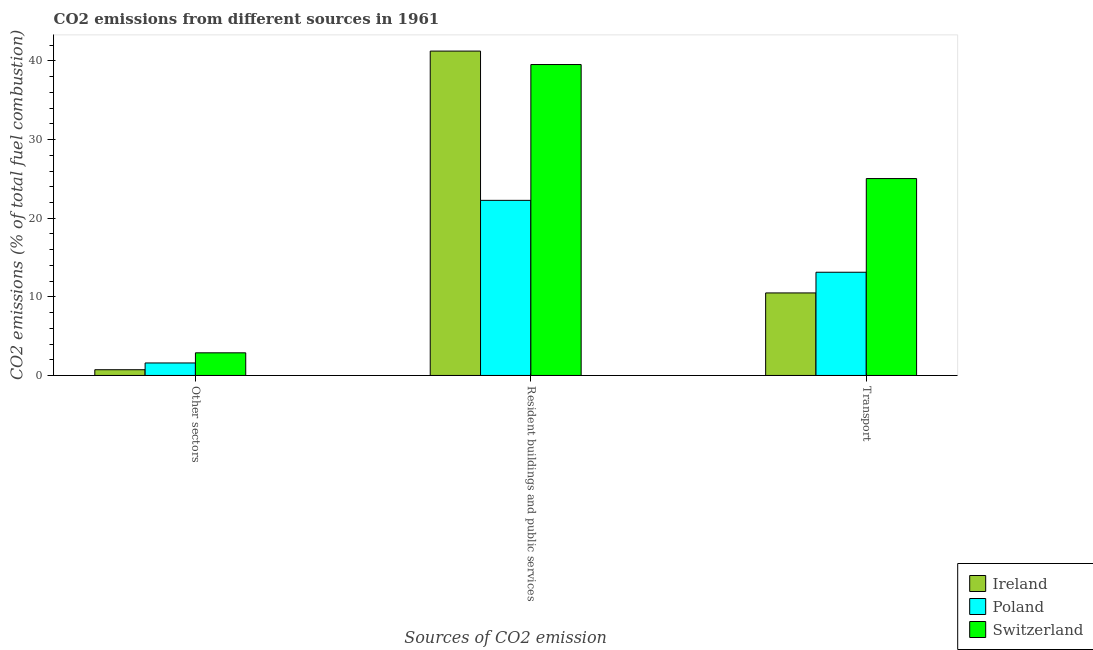How many different coloured bars are there?
Provide a succinct answer. 3. Are the number of bars on each tick of the X-axis equal?
Provide a short and direct response. Yes. How many bars are there on the 2nd tick from the right?
Offer a terse response. 3. What is the label of the 1st group of bars from the left?
Provide a short and direct response. Other sectors. What is the percentage of co2 emissions from transport in Ireland?
Make the answer very short. 10.5. Across all countries, what is the maximum percentage of co2 emissions from resident buildings and public services?
Provide a short and direct response. 41.25. Across all countries, what is the minimum percentage of co2 emissions from other sectors?
Your response must be concise. 0.73. In which country was the percentage of co2 emissions from other sectors maximum?
Keep it short and to the point. Switzerland. In which country was the percentage of co2 emissions from other sectors minimum?
Provide a short and direct response. Ireland. What is the total percentage of co2 emissions from other sectors in the graph?
Provide a succinct answer. 5.2. What is the difference between the percentage of co2 emissions from transport in Switzerland and that in Ireland?
Your answer should be very brief. 14.55. What is the difference between the percentage of co2 emissions from transport in Poland and the percentage of co2 emissions from other sectors in Ireland?
Give a very brief answer. 12.4. What is the average percentage of co2 emissions from transport per country?
Your answer should be very brief. 16.22. What is the difference between the percentage of co2 emissions from resident buildings and public services and percentage of co2 emissions from transport in Ireland?
Keep it short and to the point. 30.76. What is the ratio of the percentage of co2 emissions from transport in Switzerland to that in Ireland?
Your response must be concise. 2.39. Is the percentage of co2 emissions from transport in Ireland less than that in Poland?
Your answer should be compact. Yes. Is the difference between the percentage of co2 emissions from resident buildings and public services in Poland and Ireland greater than the difference between the percentage of co2 emissions from other sectors in Poland and Ireland?
Offer a terse response. No. What is the difference between the highest and the second highest percentage of co2 emissions from resident buildings and public services?
Keep it short and to the point. 1.71. What is the difference between the highest and the lowest percentage of co2 emissions from resident buildings and public services?
Your answer should be very brief. 18.98. In how many countries, is the percentage of co2 emissions from resident buildings and public services greater than the average percentage of co2 emissions from resident buildings and public services taken over all countries?
Provide a succinct answer. 2. Is the sum of the percentage of co2 emissions from other sectors in Ireland and Poland greater than the maximum percentage of co2 emissions from resident buildings and public services across all countries?
Keep it short and to the point. No. What does the 1st bar from the right in Transport represents?
Keep it short and to the point. Switzerland. What is the difference between two consecutive major ticks on the Y-axis?
Your response must be concise. 10. Are the values on the major ticks of Y-axis written in scientific E-notation?
Your answer should be compact. No. Does the graph contain grids?
Keep it short and to the point. No. How many legend labels are there?
Give a very brief answer. 3. What is the title of the graph?
Provide a short and direct response. CO2 emissions from different sources in 1961. Does "Albania" appear as one of the legend labels in the graph?
Your answer should be very brief. No. What is the label or title of the X-axis?
Give a very brief answer. Sources of CO2 emission. What is the label or title of the Y-axis?
Offer a very short reply. CO2 emissions (% of total fuel combustion). What is the CO2 emissions (% of total fuel combustion) in Ireland in Other sectors?
Give a very brief answer. 0.73. What is the CO2 emissions (% of total fuel combustion) of Poland in Other sectors?
Keep it short and to the point. 1.59. What is the CO2 emissions (% of total fuel combustion) in Switzerland in Other sectors?
Ensure brevity in your answer.  2.88. What is the CO2 emissions (% of total fuel combustion) of Ireland in Resident buildings and public services?
Make the answer very short. 41.25. What is the CO2 emissions (% of total fuel combustion) in Poland in Resident buildings and public services?
Your answer should be very brief. 22.27. What is the CO2 emissions (% of total fuel combustion) in Switzerland in Resident buildings and public services?
Your answer should be very brief. 39.54. What is the CO2 emissions (% of total fuel combustion) in Ireland in Transport?
Offer a very short reply. 10.5. What is the CO2 emissions (% of total fuel combustion) of Poland in Transport?
Keep it short and to the point. 13.13. What is the CO2 emissions (% of total fuel combustion) of Switzerland in Transport?
Keep it short and to the point. 25.04. Across all Sources of CO2 emission, what is the maximum CO2 emissions (% of total fuel combustion) in Ireland?
Provide a short and direct response. 41.25. Across all Sources of CO2 emission, what is the maximum CO2 emissions (% of total fuel combustion) of Poland?
Keep it short and to the point. 22.27. Across all Sources of CO2 emission, what is the maximum CO2 emissions (% of total fuel combustion) in Switzerland?
Make the answer very short. 39.54. Across all Sources of CO2 emission, what is the minimum CO2 emissions (% of total fuel combustion) in Ireland?
Make the answer very short. 0.73. Across all Sources of CO2 emission, what is the minimum CO2 emissions (% of total fuel combustion) of Poland?
Make the answer very short. 1.59. Across all Sources of CO2 emission, what is the minimum CO2 emissions (% of total fuel combustion) of Switzerland?
Give a very brief answer. 2.88. What is the total CO2 emissions (% of total fuel combustion) of Ireland in the graph?
Your answer should be very brief. 52.48. What is the total CO2 emissions (% of total fuel combustion) in Poland in the graph?
Provide a short and direct response. 36.99. What is the total CO2 emissions (% of total fuel combustion) in Switzerland in the graph?
Give a very brief answer. 67.46. What is the difference between the CO2 emissions (% of total fuel combustion) of Ireland in Other sectors and that in Resident buildings and public services?
Keep it short and to the point. -40.52. What is the difference between the CO2 emissions (% of total fuel combustion) of Poland in Other sectors and that in Resident buildings and public services?
Your response must be concise. -20.68. What is the difference between the CO2 emissions (% of total fuel combustion) in Switzerland in Other sectors and that in Resident buildings and public services?
Make the answer very short. -36.66. What is the difference between the CO2 emissions (% of total fuel combustion) of Ireland in Other sectors and that in Transport?
Give a very brief answer. -9.77. What is the difference between the CO2 emissions (% of total fuel combustion) of Poland in Other sectors and that in Transport?
Provide a short and direct response. -11.54. What is the difference between the CO2 emissions (% of total fuel combustion) in Switzerland in Other sectors and that in Transport?
Ensure brevity in your answer.  -22.16. What is the difference between the CO2 emissions (% of total fuel combustion) of Ireland in Resident buildings and public services and that in Transport?
Give a very brief answer. 30.76. What is the difference between the CO2 emissions (% of total fuel combustion) of Poland in Resident buildings and public services and that in Transport?
Offer a terse response. 9.14. What is the difference between the CO2 emissions (% of total fuel combustion) in Switzerland in Resident buildings and public services and that in Transport?
Provide a succinct answer. 14.5. What is the difference between the CO2 emissions (% of total fuel combustion) in Ireland in Other sectors and the CO2 emissions (% of total fuel combustion) in Poland in Resident buildings and public services?
Make the answer very short. -21.54. What is the difference between the CO2 emissions (% of total fuel combustion) of Ireland in Other sectors and the CO2 emissions (% of total fuel combustion) of Switzerland in Resident buildings and public services?
Provide a succinct answer. -38.81. What is the difference between the CO2 emissions (% of total fuel combustion) in Poland in Other sectors and the CO2 emissions (% of total fuel combustion) in Switzerland in Resident buildings and public services?
Offer a very short reply. -37.95. What is the difference between the CO2 emissions (% of total fuel combustion) in Ireland in Other sectors and the CO2 emissions (% of total fuel combustion) in Poland in Transport?
Make the answer very short. -12.4. What is the difference between the CO2 emissions (% of total fuel combustion) in Ireland in Other sectors and the CO2 emissions (% of total fuel combustion) in Switzerland in Transport?
Ensure brevity in your answer.  -24.31. What is the difference between the CO2 emissions (% of total fuel combustion) in Poland in Other sectors and the CO2 emissions (% of total fuel combustion) in Switzerland in Transport?
Give a very brief answer. -23.45. What is the difference between the CO2 emissions (% of total fuel combustion) in Ireland in Resident buildings and public services and the CO2 emissions (% of total fuel combustion) in Poland in Transport?
Provide a short and direct response. 28.13. What is the difference between the CO2 emissions (% of total fuel combustion) of Ireland in Resident buildings and public services and the CO2 emissions (% of total fuel combustion) of Switzerland in Transport?
Offer a very short reply. 16.21. What is the difference between the CO2 emissions (% of total fuel combustion) of Poland in Resident buildings and public services and the CO2 emissions (% of total fuel combustion) of Switzerland in Transport?
Provide a succinct answer. -2.77. What is the average CO2 emissions (% of total fuel combustion) in Ireland per Sources of CO2 emission?
Give a very brief answer. 17.49. What is the average CO2 emissions (% of total fuel combustion) of Poland per Sources of CO2 emission?
Provide a short and direct response. 12.33. What is the average CO2 emissions (% of total fuel combustion) in Switzerland per Sources of CO2 emission?
Ensure brevity in your answer.  22.49. What is the difference between the CO2 emissions (% of total fuel combustion) in Ireland and CO2 emissions (% of total fuel combustion) in Poland in Other sectors?
Give a very brief answer. -0.86. What is the difference between the CO2 emissions (% of total fuel combustion) in Ireland and CO2 emissions (% of total fuel combustion) in Switzerland in Other sectors?
Your answer should be very brief. -2.15. What is the difference between the CO2 emissions (% of total fuel combustion) in Poland and CO2 emissions (% of total fuel combustion) in Switzerland in Other sectors?
Your answer should be very brief. -1.29. What is the difference between the CO2 emissions (% of total fuel combustion) in Ireland and CO2 emissions (% of total fuel combustion) in Poland in Resident buildings and public services?
Offer a very short reply. 18.98. What is the difference between the CO2 emissions (% of total fuel combustion) of Ireland and CO2 emissions (% of total fuel combustion) of Switzerland in Resident buildings and public services?
Your answer should be very brief. 1.71. What is the difference between the CO2 emissions (% of total fuel combustion) in Poland and CO2 emissions (% of total fuel combustion) in Switzerland in Resident buildings and public services?
Offer a very short reply. -17.27. What is the difference between the CO2 emissions (% of total fuel combustion) of Ireland and CO2 emissions (% of total fuel combustion) of Poland in Transport?
Provide a short and direct response. -2.63. What is the difference between the CO2 emissions (% of total fuel combustion) in Ireland and CO2 emissions (% of total fuel combustion) in Switzerland in Transport?
Make the answer very short. -14.55. What is the difference between the CO2 emissions (% of total fuel combustion) of Poland and CO2 emissions (% of total fuel combustion) of Switzerland in Transport?
Your answer should be compact. -11.91. What is the ratio of the CO2 emissions (% of total fuel combustion) in Ireland in Other sectors to that in Resident buildings and public services?
Offer a very short reply. 0.02. What is the ratio of the CO2 emissions (% of total fuel combustion) of Poland in Other sectors to that in Resident buildings and public services?
Your response must be concise. 0.07. What is the ratio of the CO2 emissions (% of total fuel combustion) in Switzerland in Other sectors to that in Resident buildings and public services?
Offer a very short reply. 0.07. What is the ratio of the CO2 emissions (% of total fuel combustion) in Ireland in Other sectors to that in Transport?
Your answer should be very brief. 0.07. What is the ratio of the CO2 emissions (% of total fuel combustion) in Poland in Other sectors to that in Transport?
Your answer should be very brief. 0.12. What is the ratio of the CO2 emissions (% of total fuel combustion) of Switzerland in Other sectors to that in Transport?
Keep it short and to the point. 0.12. What is the ratio of the CO2 emissions (% of total fuel combustion) of Ireland in Resident buildings and public services to that in Transport?
Make the answer very short. 3.93. What is the ratio of the CO2 emissions (% of total fuel combustion) in Poland in Resident buildings and public services to that in Transport?
Your answer should be very brief. 1.7. What is the ratio of the CO2 emissions (% of total fuel combustion) of Switzerland in Resident buildings and public services to that in Transport?
Keep it short and to the point. 1.58. What is the difference between the highest and the second highest CO2 emissions (% of total fuel combustion) of Ireland?
Offer a very short reply. 30.76. What is the difference between the highest and the second highest CO2 emissions (% of total fuel combustion) in Poland?
Offer a very short reply. 9.14. What is the difference between the highest and the second highest CO2 emissions (% of total fuel combustion) of Switzerland?
Keep it short and to the point. 14.5. What is the difference between the highest and the lowest CO2 emissions (% of total fuel combustion) of Ireland?
Your answer should be compact. 40.52. What is the difference between the highest and the lowest CO2 emissions (% of total fuel combustion) in Poland?
Ensure brevity in your answer.  20.68. What is the difference between the highest and the lowest CO2 emissions (% of total fuel combustion) in Switzerland?
Offer a very short reply. 36.66. 